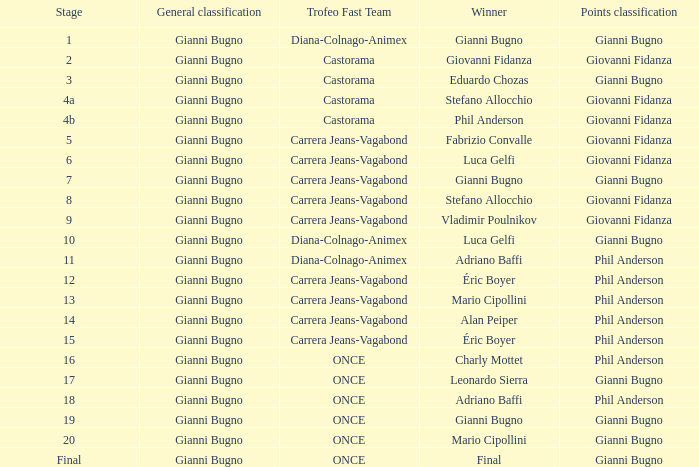Who is the winner when the trofeo fast team is carrera jeans-vagabond in stage 5? Fabrizio Convalle. 